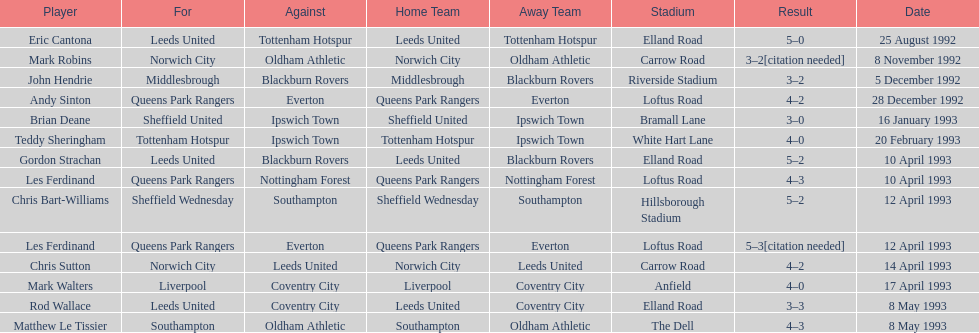What was the result of the match between queens park rangers and everton? 4-2. 